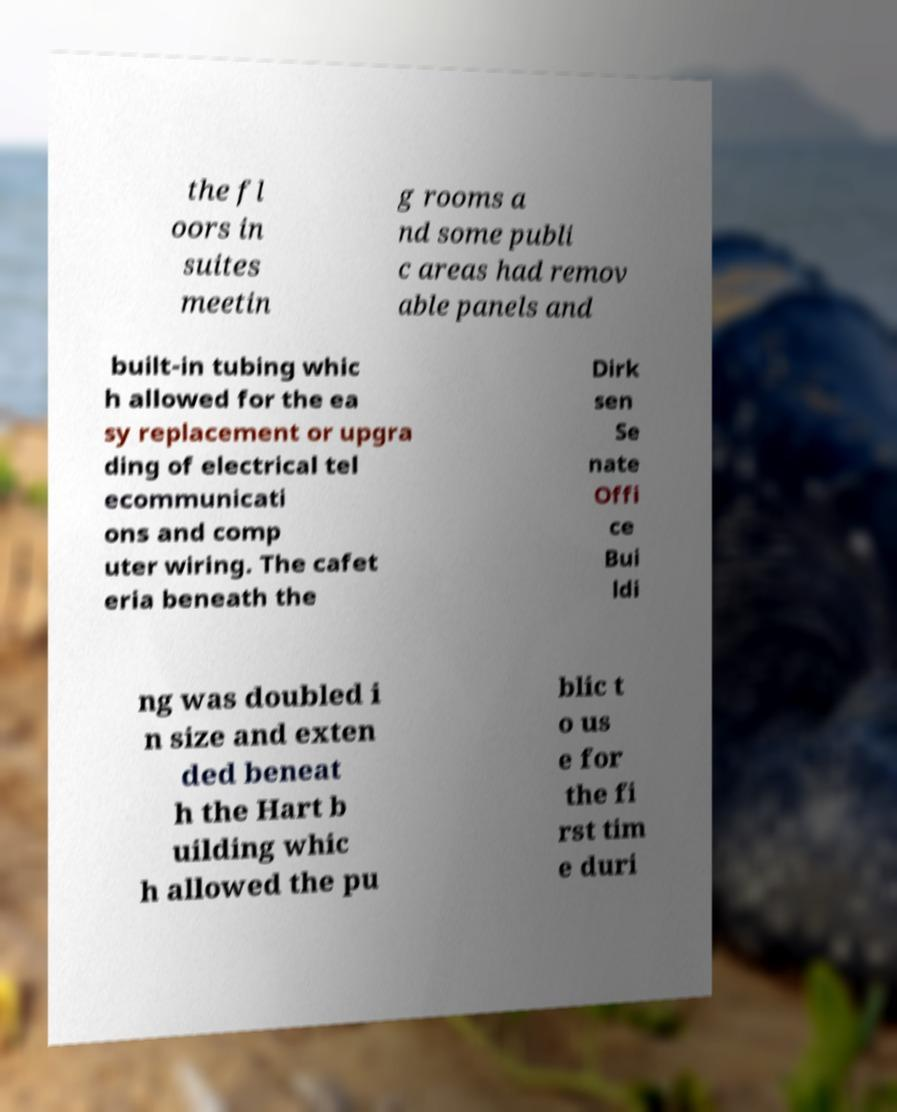Can you accurately transcribe the text from the provided image for me? the fl oors in suites meetin g rooms a nd some publi c areas had remov able panels and built-in tubing whic h allowed for the ea sy replacement or upgra ding of electrical tel ecommunicati ons and comp uter wiring. The cafet eria beneath the Dirk sen Se nate Offi ce Bui ldi ng was doubled i n size and exten ded beneat h the Hart b uilding whic h allowed the pu blic t o us e for the fi rst tim e duri 